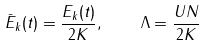<formula> <loc_0><loc_0><loc_500><loc_500>\bar { E } _ { k } ( t ) = \frac { E _ { k } ( t ) } { 2 K } , \quad \Lambda = \frac { U N } { 2 K }</formula> 